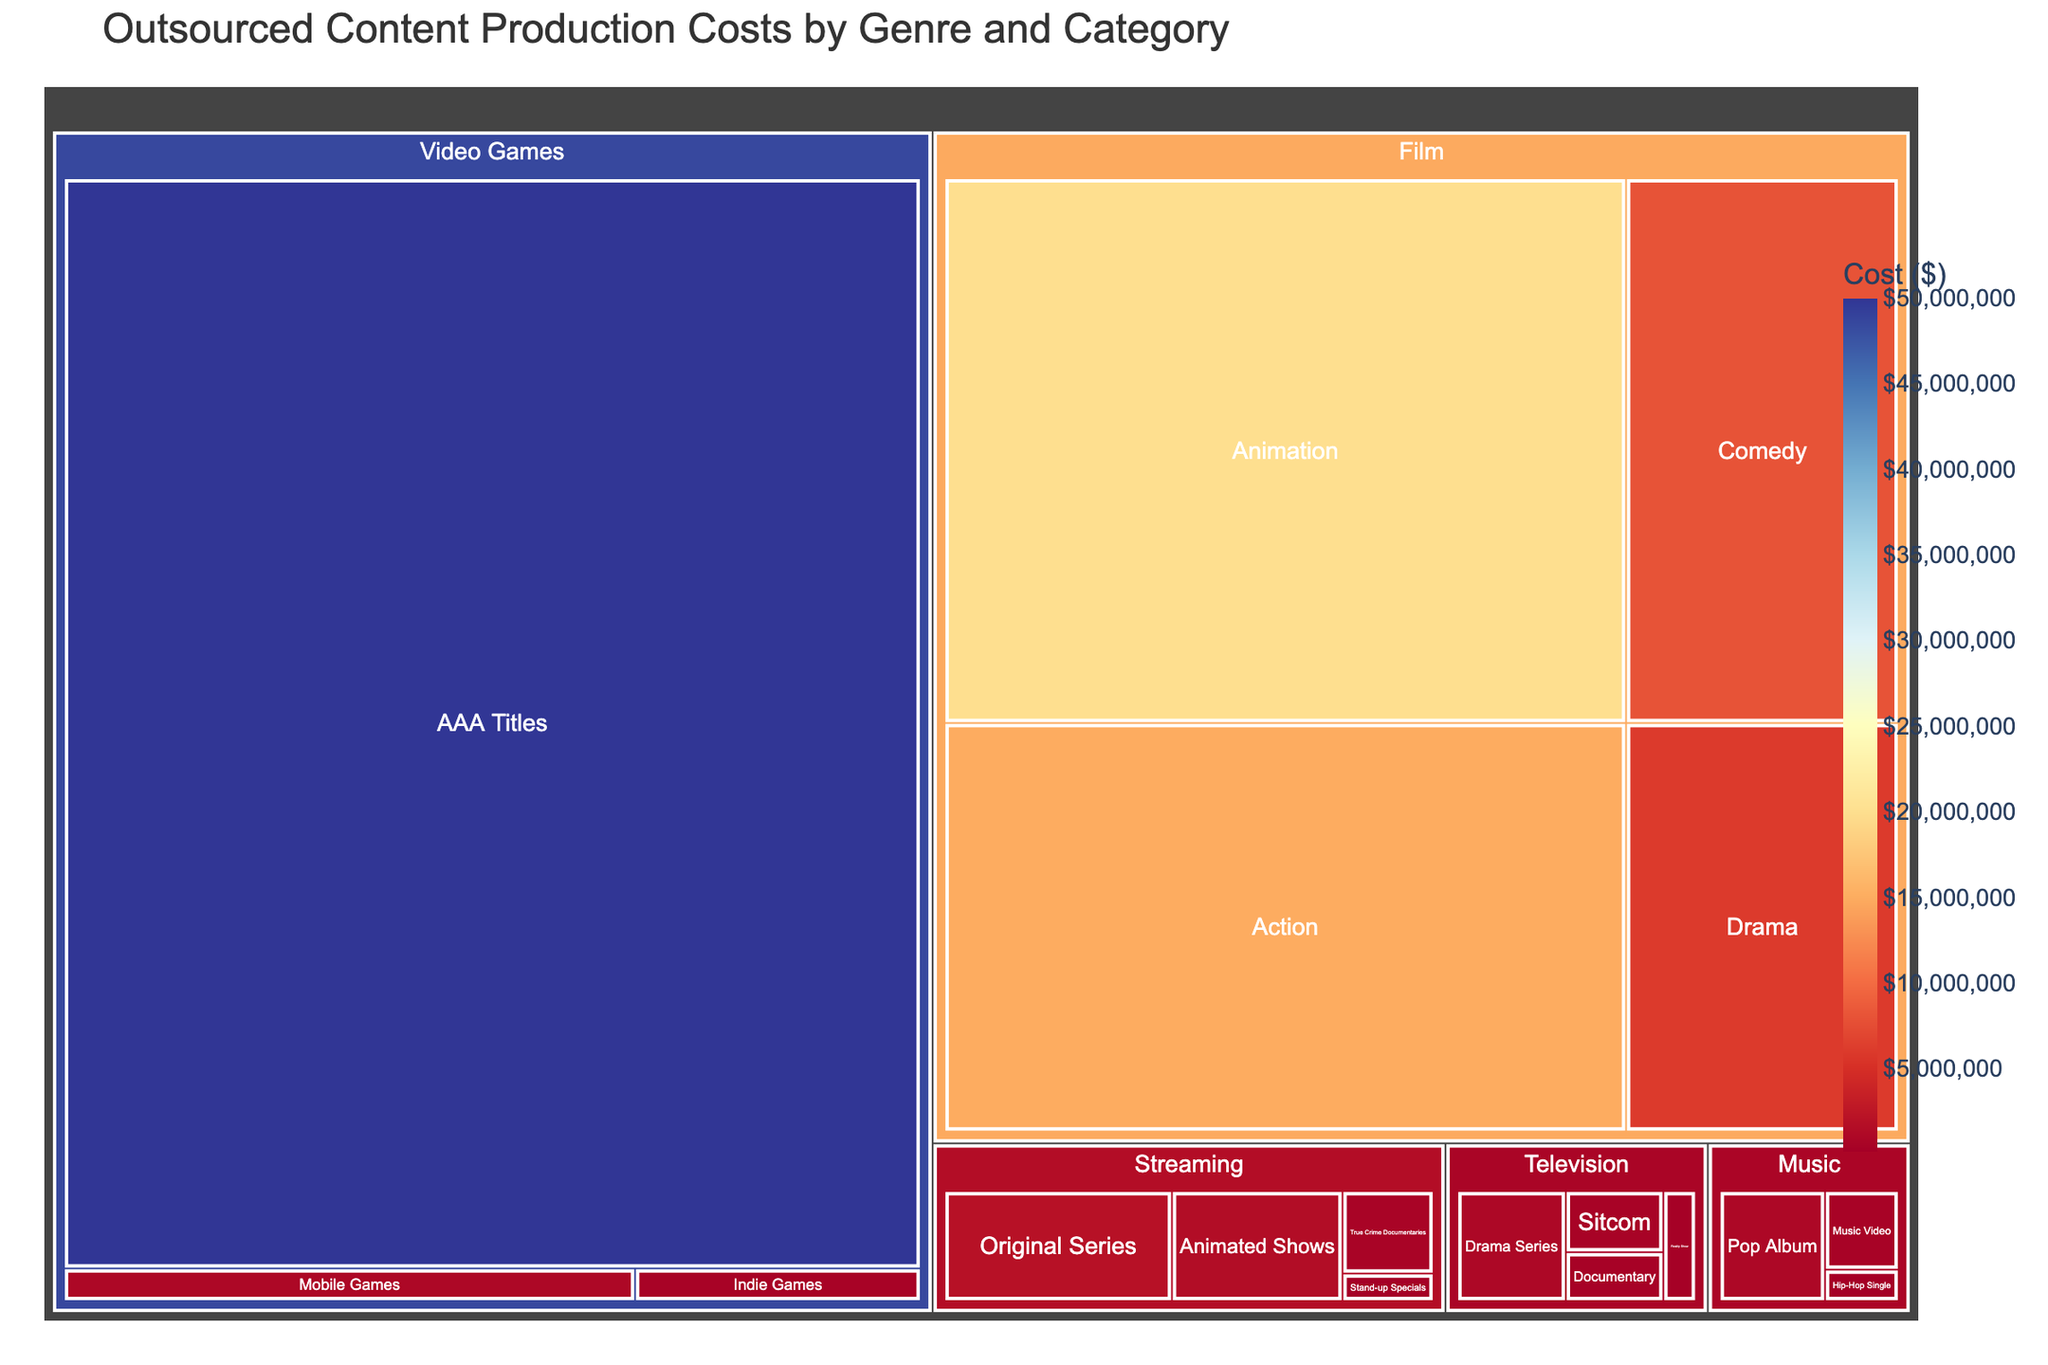What's the largest cost category in the Video Games genre? To find the largest cost category within the Video Games genre, look at the section labeled "Video Games" and identify the category with the highest cost. The "AAA Titles" subcategory has the largest area, indicating the highest cost.
Answer: AAA Titles What's the combined cost of Drama Series and True Crime Documentaries? First, locate the cost for "Drama Series" under Television, which is $1,000,000, and "True Crime Documentaries" under Streaming, which is $600,000. Summing these values gives $1,000,000 + $600,000.
Answer: $1,600,000 Which genre has the lowest total production cost? Scan the treemap for the genre with the smallest combined area of its sections. Music appears to be the smallest, with individual costs of $1,000,000 (Pop Album), $200,000 (Hip-Hop Single), and $500,000 (Music Video), totaling $1,700,000.
Answer: Music How does the cost for Action films compare to Animated films? Identify both categories under the Film genre. Action films cost $15,000,000, while Animation costs $20,000,000. Comparing these values shows that Animated films have higher costs.
Answer: Animation costs more What's the combined cost of all categories under the Television genre? Add the costs for all categories under Television: Sitcom ($500,000), Reality Show ($300,000), Drama Series ($1,000,000), and Documentary ($400,000). The sum is $500,000 + $300,000 + $1,000,000 + $400,000.
Answer: $2,200,000 In which genre does the category 'AAA Titles' fall? To find the genre containing 'AAA Titles,' locate 'AAA Titles' on the treemap, which falls under the genre Video Games.
Answer: Video Games What are the highest and lowest costs associated with the categories under the Streaming genre? Identify the costs of all categories under Streaming. The costs are: Original Series ($2,000,000), Animated Shows ($1,500,000), Stand-up Specials ($200,000), and True Crime Documentaries ($600,000). The highest is $2,000,000 and the lowest is $200,000.
Answer: Highest: $2,000,000, Lowest: $200,000 What's the total production cost for all Film genres combined? Sum the costs under Film: Action ($15,000,000), Comedy ($8,000,000), Drama ($6,000,000), and Animation ($20,000,000). The combined total is $15,000,000 + $8,000,000 + $6,000,000 + $20,000,000.
Answer: $49,000,000 